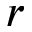<formula> <loc_0><loc_0><loc_500><loc_500>r</formula> 